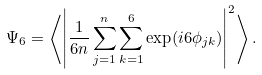<formula> <loc_0><loc_0><loc_500><loc_500>\Psi _ { 6 } = \left \langle \left | \frac { 1 } { 6 n } \sum _ { j = 1 } ^ { n } \sum _ { k = 1 } ^ { 6 } \exp ( i 6 \phi _ { j k } ) \right | ^ { 2 } \right \rangle .</formula> 